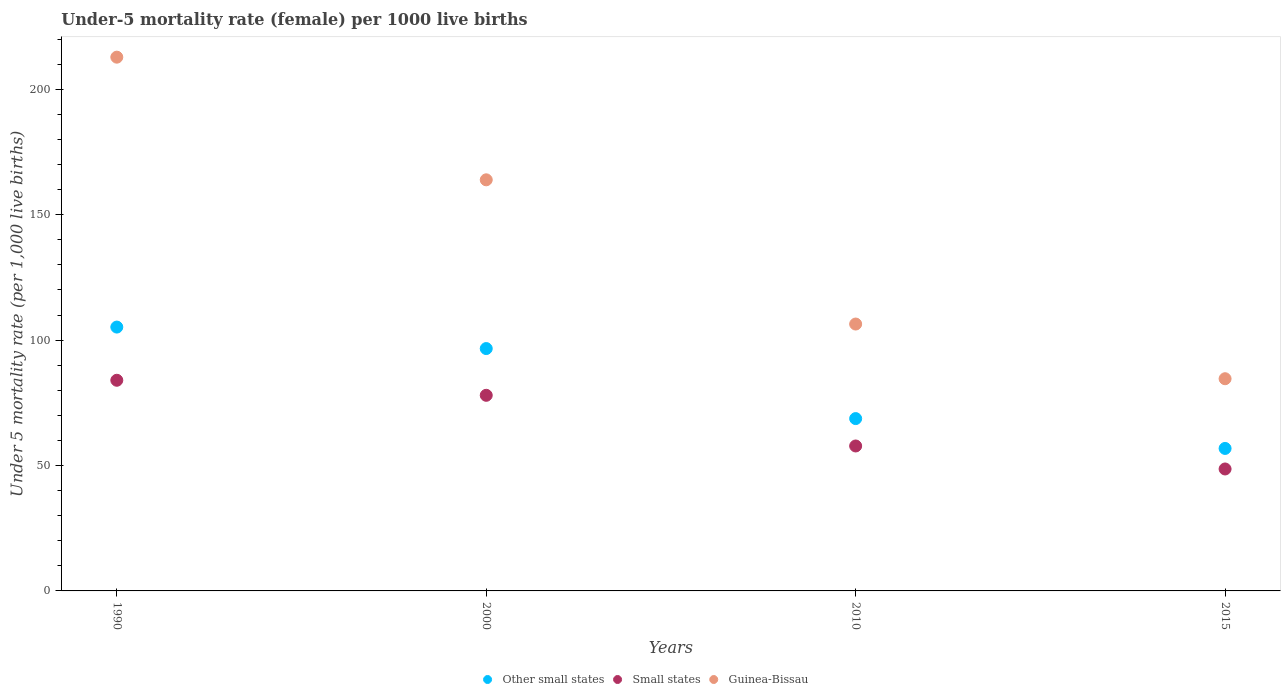How many different coloured dotlines are there?
Provide a succinct answer. 3. What is the under-five mortality rate in Other small states in 2015?
Give a very brief answer. 56.81. Across all years, what is the maximum under-five mortality rate in Small states?
Your answer should be very brief. 83.98. Across all years, what is the minimum under-five mortality rate in Guinea-Bissau?
Keep it short and to the point. 84.6. In which year was the under-five mortality rate in Other small states maximum?
Offer a very short reply. 1990. In which year was the under-five mortality rate in Other small states minimum?
Make the answer very short. 2015. What is the total under-five mortality rate in Other small states in the graph?
Your answer should be very brief. 327.33. What is the difference between the under-five mortality rate in Other small states in 1990 and that in 2000?
Ensure brevity in your answer.  8.57. What is the difference between the under-five mortality rate in Small states in 2015 and the under-five mortality rate in Guinea-Bissau in 2010?
Provide a succinct answer. -57.78. What is the average under-five mortality rate in Other small states per year?
Provide a short and direct response. 81.83. In the year 2000, what is the difference between the under-five mortality rate in Other small states and under-five mortality rate in Small states?
Keep it short and to the point. 18.64. In how many years, is the under-five mortality rate in Small states greater than 70?
Your answer should be very brief. 2. What is the ratio of the under-five mortality rate in Small states in 2010 to that in 2015?
Your answer should be very brief. 1.19. Is the under-five mortality rate in Guinea-Bissau in 2000 less than that in 2015?
Provide a succinct answer. No. What is the difference between the highest and the second highest under-five mortality rate in Other small states?
Your answer should be compact. 8.57. What is the difference between the highest and the lowest under-five mortality rate in Guinea-Bissau?
Ensure brevity in your answer.  128.2. In how many years, is the under-five mortality rate in Other small states greater than the average under-five mortality rate in Other small states taken over all years?
Provide a short and direct response. 2. Is the sum of the under-five mortality rate in Other small states in 1990 and 2015 greater than the maximum under-five mortality rate in Small states across all years?
Your response must be concise. Yes. Is the under-five mortality rate in Other small states strictly greater than the under-five mortality rate in Small states over the years?
Make the answer very short. Yes. Is the under-five mortality rate in Other small states strictly less than the under-five mortality rate in Small states over the years?
Offer a terse response. No. How many dotlines are there?
Give a very brief answer. 3. How many years are there in the graph?
Provide a short and direct response. 4. Are the values on the major ticks of Y-axis written in scientific E-notation?
Your answer should be very brief. No. Does the graph contain any zero values?
Provide a succinct answer. No. Does the graph contain grids?
Keep it short and to the point. No. How many legend labels are there?
Offer a terse response. 3. How are the legend labels stacked?
Give a very brief answer. Horizontal. What is the title of the graph?
Offer a very short reply. Under-5 mortality rate (female) per 1000 live births. What is the label or title of the Y-axis?
Your response must be concise. Under 5 mortality rate (per 1,0 live births). What is the Under 5 mortality rate (per 1,000 live births) in Other small states in 1990?
Your answer should be very brief. 105.19. What is the Under 5 mortality rate (per 1,000 live births) in Small states in 1990?
Give a very brief answer. 83.98. What is the Under 5 mortality rate (per 1,000 live births) of Guinea-Bissau in 1990?
Your answer should be very brief. 212.8. What is the Under 5 mortality rate (per 1,000 live births) in Other small states in 2000?
Your answer should be very brief. 96.62. What is the Under 5 mortality rate (per 1,000 live births) in Small states in 2000?
Give a very brief answer. 77.99. What is the Under 5 mortality rate (per 1,000 live births) in Guinea-Bissau in 2000?
Provide a succinct answer. 163.9. What is the Under 5 mortality rate (per 1,000 live births) of Other small states in 2010?
Keep it short and to the point. 68.7. What is the Under 5 mortality rate (per 1,000 live births) in Small states in 2010?
Your response must be concise. 57.78. What is the Under 5 mortality rate (per 1,000 live births) in Guinea-Bissau in 2010?
Provide a short and direct response. 106.4. What is the Under 5 mortality rate (per 1,000 live births) of Other small states in 2015?
Offer a very short reply. 56.81. What is the Under 5 mortality rate (per 1,000 live births) of Small states in 2015?
Give a very brief answer. 48.62. What is the Under 5 mortality rate (per 1,000 live births) in Guinea-Bissau in 2015?
Ensure brevity in your answer.  84.6. Across all years, what is the maximum Under 5 mortality rate (per 1,000 live births) in Other small states?
Give a very brief answer. 105.19. Across all years, what is the maximum Under 5 mortality rate (per 1,000 live births) in Small states?
Your answer should be compact. 83.98. Across all years, what is the maximum Under 5 mortality rate (per 1,000 live births) of Guinea-Bissau?
Your answer should be compact. 212.8. Across all years, what is the minimum Under 5 mortality rate (per 1,000 live births) in Other small states?
Make the answer very short. 56.81. Across all years, what is the minimum Under 5 mortality rate (per 1,000 live births) in Small states?
Keep it short and to the point. 48.62. Across all years, what is the minimum Under 5 mortality rate (per 1,000 live births) in Guinea-Bissau?
Your answer should be compact. 84.6. What is the total Under 5 mortality rate (per 1,000 live births) of Other small states in the graph?
Offer a terse response. 327.33. What is the total Under 5 mortality rate (per 1,000 live births) of Small states in the graph?
Provide a short and direct response. 268.37. What is the total Under 5 mortality rate (per 1,000 live births) of Guinea-Bissau in the graph?
Your answer should be very brief. 567.7. What is the difference between the Under 5 mortality rate (per 1,000 live births) of Other small states in 1990 and that in 2000?
Offer a very short reply. 8.57. What is the difference between the Under 5 mortality rate (per 1,000 live births) of Small states in 1990 and that in 2000?
Offer a terse response. 6. What is the difference between the Under 5 mortality rate (per 1,000 live births) in Guinea-Bissau in 1990 and that in 2000?
Provide a short and direct response. 48.9. What is the difference between the Under 5 mortality rate (per 1,000 live births) of Other small states in 1990 and that in 2010?
Give a very brief answer. 36.49. What is the difference between the Under 5 mortality rate (per 1,000 live births) in Small states in 1990 and that in 2010?
Make the answer very short. 26.2. What is the difference between the Under 5 mortality rate (per 1,000 live births) in Guinea-Bissau in 1990 and that in 2010?
Make the answer very short. 106.4. What is the difference between the Under 5 mortality rate (per 1,000 live births) in Other small states in 1990 and that in 2015?
Provide a succinct answer. 48.38. What is the difference between the Under 5 mortality rate (per 1,000 live births) of Small states in 1990 and that in 2015?
Make the answer very short. 35.37. What is the difference between the Under 5 mortality rate (per 1,000 live births) of Guinea-Bissau in 1990 and that in 2015?
Offer a very short reply. 128.2. What is the difference between the Under 5 mortality rate (per 1,000 live births) in Other small states in 2000 and that in 2010?
Make the answer very short. 27.92. What is the difference between the Under 5 mortality rate (per 1,000 live births) of Small states in 2000 and that in 2010?
Your answer should be very brief. 20.2. What is the difference between the Under 5 mortality rate (per 1,000 live births) in Guinea-Bissau in 2000 and that in 2010?
Your response must be concise. 57.5. What is the difference between the Under 5 mortality rate (per 1,000 live births) of Other small states in 2000 and that in 2015?
Keep it short and to the point. 39.82. What is the difference between the Under 5 mortality rate (per 1,000 live births) of Small states in 2000 and that in 2015?
Provide a succinct answer. 29.37. What is the difference between the Under 5 mortality rate (per 1,000 live births) of Guinea-Bissau in 2000 and that in 2015?
Ensure brevity in your answer.  79.3. What is the difference between the Under 5 mortality rate (per 1,000 live births) of Other small states in 2010 and that in 2015?
Ensure brevity in your answer.  11.9. What is the difference between the Under 5 mortality rate (per 1,000 live births) in Small states in 2010 and that in 2015?
Give a very brief answer. 9.17. What is the difference between the Under 5 mortality rate (per 1,000 live births) of Guinea-Bissau in 2010 and that in 2015?
Provide a succinct answer. 21.8. What is the difference between the Under 5 mortality rate (per 1,000 live births) in Other small states in 1990 and the Under 5 mortality rate (per 1,000 live births) in Small states in 2000?
Ensure brevity in your answer.  27.2. What is the difference between the Under 5 mortality rate (per 1,000 live births) in Other small states in 1990 and the Under 5 mortality rate (per 1,000 live births) in Guinea-Bissau in 2000?
Ensure brevity in your answer.  -58.71. What is the difference between the Under 5 mortality rate (per 1,000 live births) in Small states in 1990 and the Under 5 mortality rate (per 1,000 live births) in Guinea-Bissau in 2000?
Keep it short and to the point. -79.92. What is the difference between the Under 5 mortality rate (per 1,000 live births) in Other small states in 1990 and the Under 5 mortality rate (per 1,000 live births) in Small states in 2010?
Offer a very short reply. 47.41. What is the difference between the Under 5 mortality rate (per 1,000 live births) in Other small states in 1990 and the Under 5 mortality rate (per 1,000 live births) in Guinea-Bissau in 2010?
Keep it short and to the point. -1.21. What is the difference between the Under 5 mortality rate (per 1,000 live births) of Small states in 1990 and the Under 5 mortality rate (per 1,000 live births) of Guinea-Bissau in 2010?
Your response must be concise. -22.42. What is the difference between the Under 5 mortality rate (per 1,000 live births) in Other small states in 1990 and the Under 5 mortality rate (per 1,000 live births) in Small states in 2015?
Provide a succinct answer. 56.57. What is the difference between the Under 5 mortality rate (per 1,000 live births) in Other small states in 1990 and the Under 5 mortality rate (per 1,000 live births) in Guinea-Bissau in 2015?
Provide a short and direct response. 20.59. What is the difference between the Under 5 mortality rate (per 1,000 live births) in Small states in 1990 and the Under 5 mortality rate (per 1,000 live births) in Guinea-Bissau in 2015?
Your answer should be compact. -0.62. What is the difference between the Under 5 mortality rate (per 1,000 live births) of Other small states in 2000 and the Under 5 mortality rate (per 1,000 live births) of Small states in 2010?
Offer a terse response. 38.84. What is the difference between the Under 5 mortality rate (per 1,000 live births) in Other small states in 2000 and the Under 5 mortality rate (per 1,000 live births) in Guinea-Bissau in 2010?
Provide a succinct answer. -9.78. What is the difference between the Under 5 mortality rate (per 1,000 live births) in Small states in 2000 and the Under 5 mortality rate (per 1,000 live births) in Guinea-Bissau in 2010?
Offer a very short reply. -28.41. What is the difference between the Under 5 mortality rate (per 1,000 live births) of Other small states in 2000 and the Under 5 mortality rate (per 1,000 live births) of Small states in 2015?
Your answer should be compact. 48.01. What is the difference between the Under 5 mortality rate (per 1,000 live births) of Other small states in 2000 and the Under 5 mortality rate (per 1,000 live births) of Guinea-Bissau in 2015?
Your answer should be very brief. 12.02. What is the difference between the Under 5 mortality rate (per 1,000 live births) of Small states in 2000 and the Under 5 mortality rate (per 1,000 live births) of Guinea-Bissau in 2015?
Give a very brief answer. -6.61. What is the difference between the Under 5 mortality rate (per 1,000 live births) of Other small states in 2010 and the Under 5 mortality rate (per 1,000 live births) of Small states in 2015?
Your answer should be compact. 20.09. What is the difference between the Under 5 mortality rate (per 1,000 live births) in Other small states in 2010 and the Under 5 mortality rate (per 1,000 live births) in Guinea-Bissau in 2015?
Keep it short and to the point. -15.9. What is the difference between the Under 5 mortality rate (per 1,000 live births) of Small states in 2010 and the Under 5 mortality rate (per 1,000 live births) of Guinea-Bissau in 2015?
Provide a succinct answer. -26.82. What is the average Under 5 mortality rate (per 1,000 live births) in Other small states per year?
Offer a very short reply. 81.83. What is the average Under 5 mortality rate (per 1,000 live births) of Small states per year?
Make the answer very short. 67.09. What is the average Under 5 mortality rate (per 1,000 live births) of Guinea-Bissau per year?
Ensure brevity in your answer.  141.93. In the year 1990, what is the difference between the Under 5 mortality rate (per 1,000 live births) of Other small states and Under 5 mortality rate (per 1,000 live births) of Small states?
Make the answer very short. 21.21. In the year 1990, what is the difference between the Under 5 mortality rate (per 1,000 live births) in Other small states and Under 5 mortality rate (per 1,000 live births) in Guinea-Bissau?
Give a very brief answer. -107.61. In the year 1990, what is the difference between the Under 5 mortality rate (per 1,000 live births) in Small states and Under 5 mortality rate (per 1,000 live births) in Guinea-Bissau?
Make the answer very short. -128.82. In the year 2000, what is the difference between the Under 5 mortality rate (per 1,000 live births) in Other small states and Under 5 mortality rate (per 1,000 live births) in Small states?
Your answer should be compact. 18.64. In the year 2000, what is the difference between the Under 5 mortality rate (per 1,000 live births) in Other small states and Under 5 mortality rate (per 1,000 live births) in Guinea-Bissau?
Provide a succinct answer. -67.28. In the year 2000, what is the difference between the Under 5 mortality rate (per 1,000 live births) in Small states and Under 5 mortality rate (per 1,000 live births) in Guinea-Bissau?
Provide a succinct answer. -85.91. In the year 2010, what is the difference between the Under 5 mortality rate (per 1,000 live births) of Other small states and Under 5 mortality rate (per 1,000 live births) of Small states?
Your answer should be very brief. 10.92. In the year 2010, what is the difference between the Under 5 mortality rate (per 1,000 live births) in Other small states and Under 5 mortality rate (per 1,000 live births) in Guinea-Bissau?
Make the answer very short. -37.7. In the year 2010, what is the difference between the Under 5 mortality rate (per 1,000 live births) in Small states and Under 5 mortality rate (per 1,000 live births) in Guinea-Bissau?
Provide a succinct answer. -48.62. In the year 2015, what is the difference between the Under 5 mortality rate (per 1,000 live births) in Other small states and Under 5 mortality rate (per 1,000 live births) in Small states?
Provide a short and direct response. 8.19. In the year 2015, what is the difference between the Under 5 mortality rate (per 1,000 live births) in Other small states and Under 5 mortality rate (per 1,000 live births) in Guinea-Bissau?
Offer a very short reply. -27.79. In the year 2015, what is the difference between the Under 5 mortality rate (per 1,000 live births) of Small states and Under 5 mortality rate (per 1,000 live births) of Guinea-Bissau?
Keep it short and to the point. -35.98. What is the ratio of the Under 5 mortality rate (per 1,000 live births) of Other small states in 1990 to that in 2000?
Keep it short and to the point. 1.09. What is the ratio of the Under 5 mortality rate (per 1,000 live births) in Small states in 1990 to that in 2000?
Your answer should be compact. 1.08. What is the ratio of the Under 5 mortality rate (per 1,000 live births) in Guinea-Bissau in 1990 to that in 2000?
Keep it short and to the point. 1.3. What is the ratio of the Under 5 mortality rate (per 1,000 live births) in Other small states in 1990 to that in 2010?
Your answer should be compact. 1.53. What is the ratio of the Under 5 mortality rate (per 1,000 live births) of Small states in 1990 to that in 2010?
Make the answer very short. 1.45. What is the ratio of the Under 5 mortality rate (per 1,000 live births) in Other small states in 1990 to that in 2015?
Provide a succinct answer. 1.85. What is the ratio of the Under 5 mortality rate (per 1,000 live births) of Small states in 1990 to that in 2015?
Offer a terse response. 1.73. What is the ratio of the Under 5 mortality rate (per 1,000 live births) of Guinea-Bissau in 1990 to that in 2015?
Ensure brevity in your answer.  2.52. What is the ratio of the Under 5 mortality rate (per 1,000 live births) in Other small states in 2000 to that in 2010?
Provide a short and direct response. 1.41. What is the ratio of the Under 5 mortality rate (per 1,000 live births) of Small states in 2000 to that in 2010?
Offer a terse response. 1.35. What is the ratio of the Under 5 mortality rate (per 1,000 live births) in Guinea-Bissau in 2000 to that in 2010?
Your answer should be compact. 1.54. What is the ratio of the Under 5 mortality rate (per 1,000 live births) of Other small states in 2000 to that in 2015?
Ensure brevity in your answer.  1.7. What is the ratio of the Under 5 mortality rate (per 1,000 live births) in Small states in 2000 to that in 2015?
Your answer should be compact. 1.6. What is the ratio of the Under 5 mortality rate (per 1,000 live births) in Guinea-Bissau in 2000 to that in 2015?
Offer a terse response. 1.94. What is the ratio of the Under 5 mortality rate (per 1,000 live births) in Other small states in 2010 to that in 2015?
Keep it short and to the point. 1.21. What is the ratio of the Under 5 mortality rate (per 1,000 live births) of Small states in 2010 to that in 2015?
Your answer should be very brief. 1.19. What is the ratio of the Under 5 mortality rate (per 1,000 live births) of Guinea-Bissau in 2010 to that in 2015?
Provide a short and direct response. 1.26. What is the difference between the highest and the second highest Under 5 mortality rate (per 1,000 live births) in Other small states?
Your response must be concise. 8.57. What is the difference between the highest and the second highest Under 5 mortality rate (per 1,000 live births) in Small states?
Ensure brevity in your answer.  6. What is the difference between the highest and the second highest Under 5 mortality rate (per 1,000 live births) in Guinea-Bissau?
Ensure brevity in your answer.  48.9. What is the difference between the highest and the lowest Under 5 mortality rate (per 1,000 live births) of Other small states?
Provide a short and direct response. 48.38. What is the difference between the highest and the lowest Under 5 mortality rate (per 1,000 live births) in Small states?
Provide a short and direct response. 35.37. What is the difference between the highest and the lowest Under 5 mortality rate (per 1,000 live births) in Guinea-Bissau?
Offer a terse response. 128.2. 